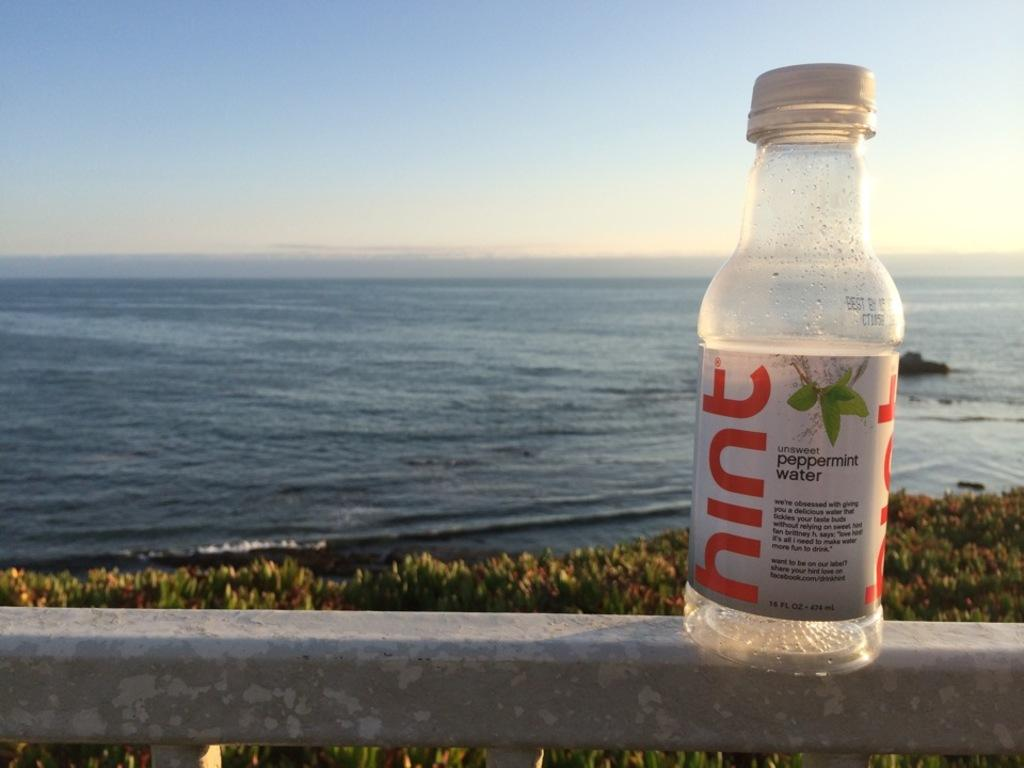<image>
Provide a brief description of the given image. A bottle of "hint" peppermint water on the ledge of a banister as the background of an ocean. 